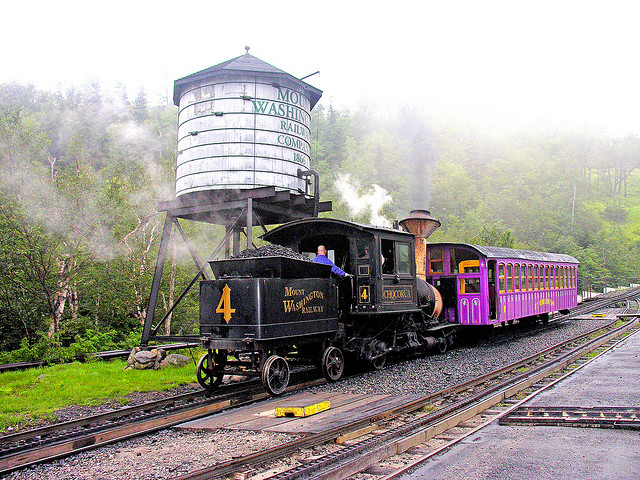Identify the text displayed in this image. MOUN WASHING RAILW COMPA 1866 4 RAILWAY WASHINGTON MOUNT 4 